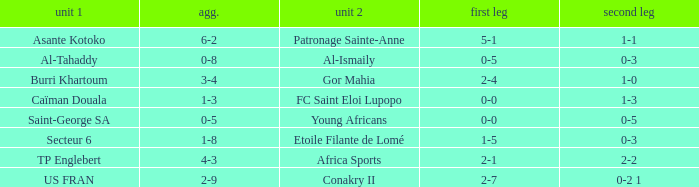Which teams had a total score of 3-4? Burri Khartoum. 